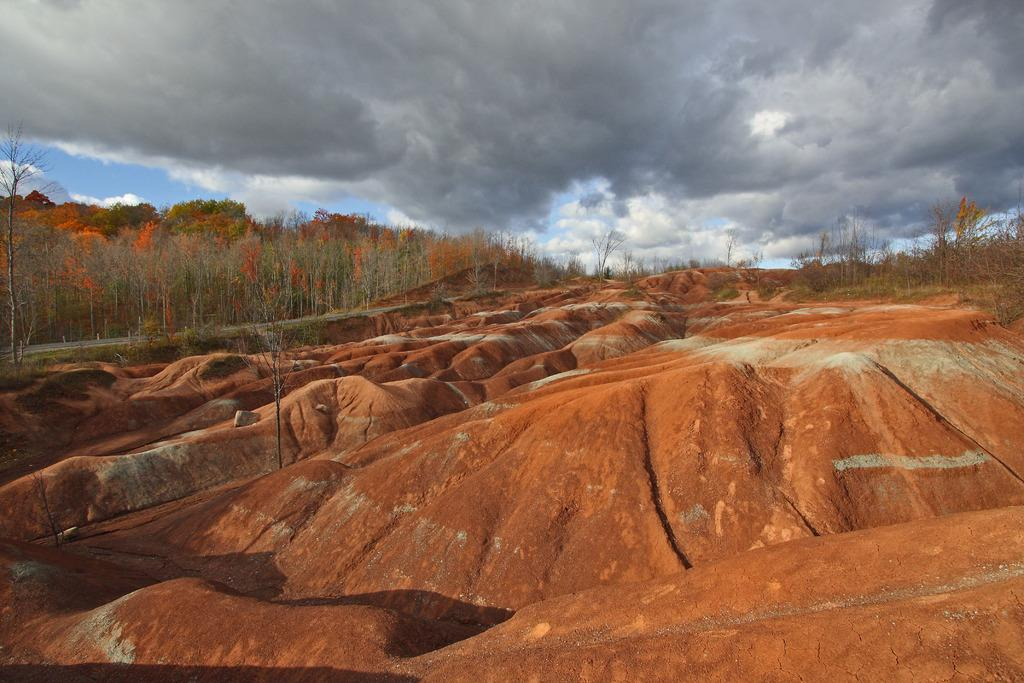What is present in the foreground of the image? There is mud in the foreground of the image. What can be seen in the background of the image? There is a road and trees in the background of the image. What else is visible in the background of the image? The sky is visible in the background of the image. What color is the lipstick on the notebook in the image? There is no lipstick or notebook present in the image. How many beads are visible on the tree in the image? There are no beads present on the trees in the image. 